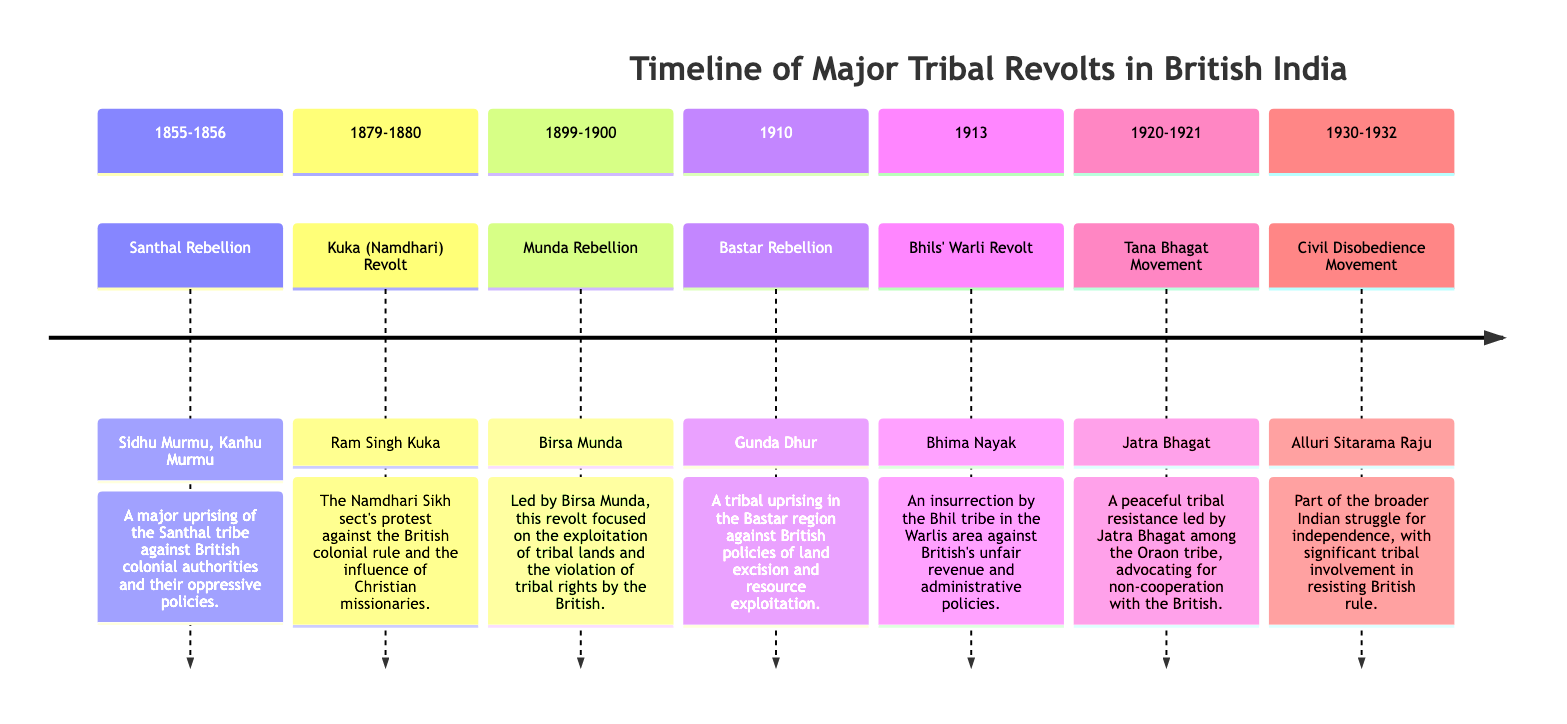What is the time range of the Santhal Rebellion? The Santhal Rebellion occurred between the years 1855 to 1856 as indicated in the timeline section.
Answer: 1855-1856 Who led the Munda Rebellion? The leader of the Munda Rebellion is Birsa Munda, as mentioned in the corresponding section of the timeline.
Answer: Birsa Munda What event is associated with the year 1910? The timeline specifically shows the Bastar Rebellion taking place in the year 1910.
Answer: Bastar Rebellion How many tribal revolts are listed in the diagram? Counting the unique events shown, there are a total of six tribal revolts listed in the timeline sections.
Answer: 6 Which revolt focused on non-cooperation with the British? The Tana Bhagat Movement is noted in the timeline as a peaceful resistance advocating non-cooperation with British authorities.
Answer: Tana Bhagat Movement In which century did the Kuka (Namdhari) Revolt occur? The Kuka (Namdhari) Revolt is located in the 19th century based on its time frame of 1879-1880.
Answer: 19th century How are the revolts arranged in the diagram? The revolts are arranged chronologically along a timeline, indicating their occurrence in the order of years.
Answer: Chronologically What was a primary cause of the Munda Rebellion? The Munda Rebellion was centered on the exploitation of tribal lands and violation of tribal rights by the British.
Answer: Exploitation of tribal lands Which leader is associated with the Civil Disobedience Movement? The Civil Disobedience Movement is associated with Alluri Sitarama Raju, as indicated in the section of the timeline.
Answer: Alluri Sitarama Raju 